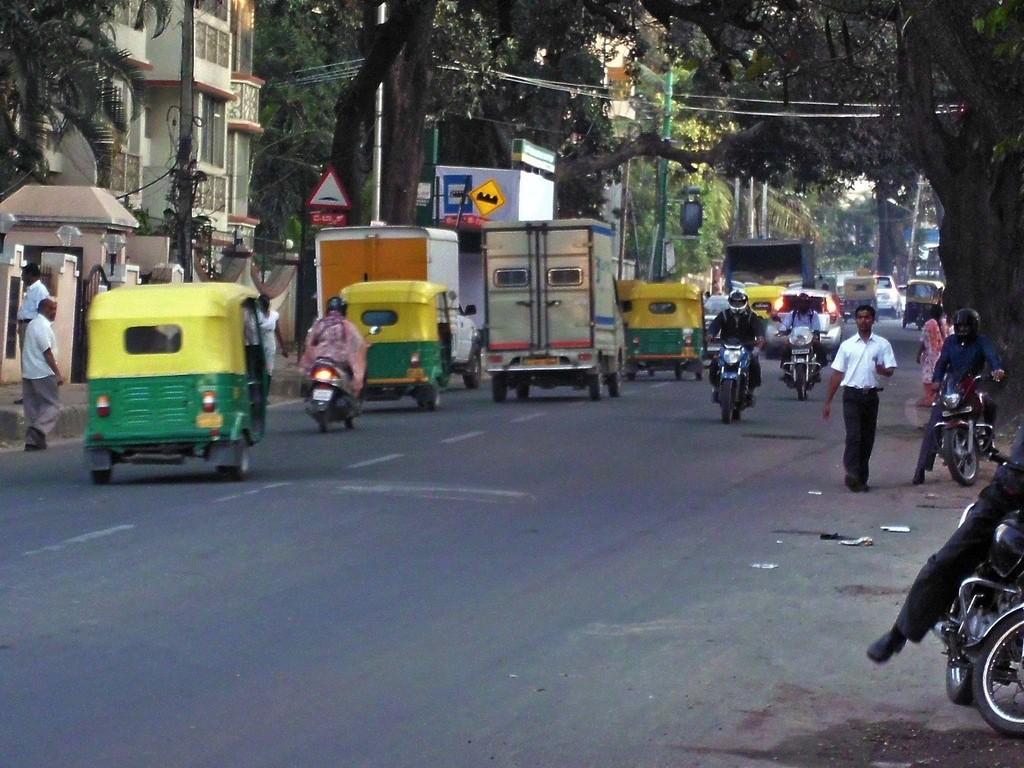How would you summarize this image in a sentence or two? In this image we can see some vehicles moving on the road there are some persons walking, at left and right side of the image there are some trees, buildings and there are some signage boards. 